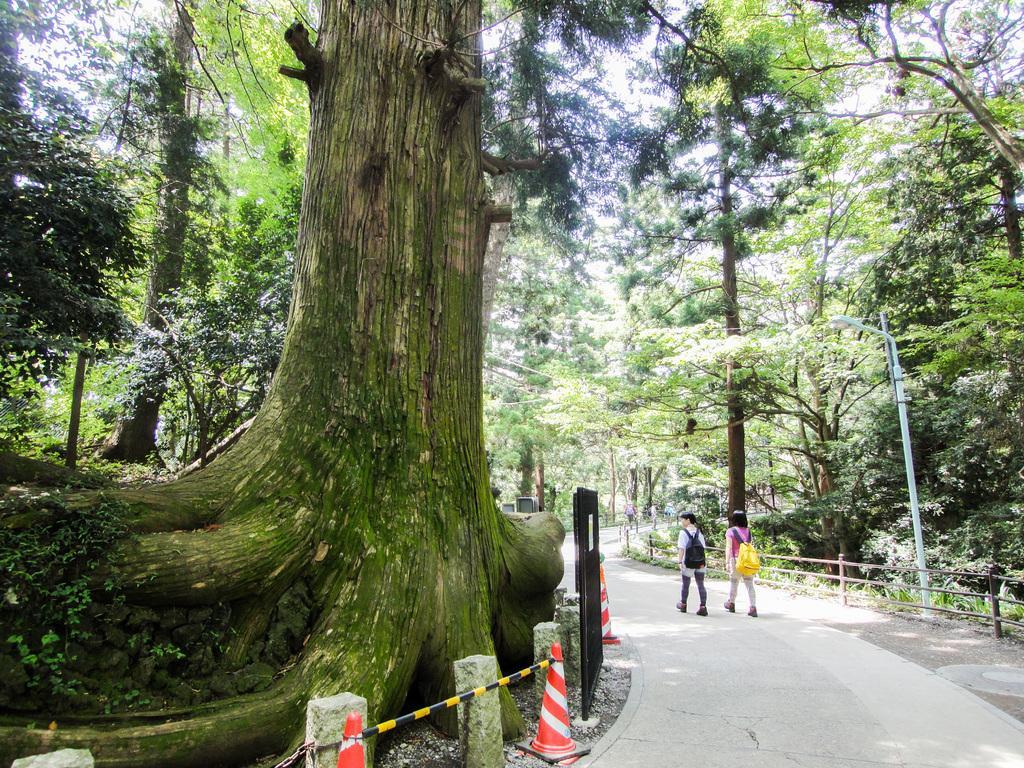Please provide a concise description of this image. To the left side of the image there are big trees. In front of the tree there is a stone fencing. To the right bottom of the image there is a road with two people are walking. To the right corner there are trees and also there is a fencing. In the background there are many trees. 